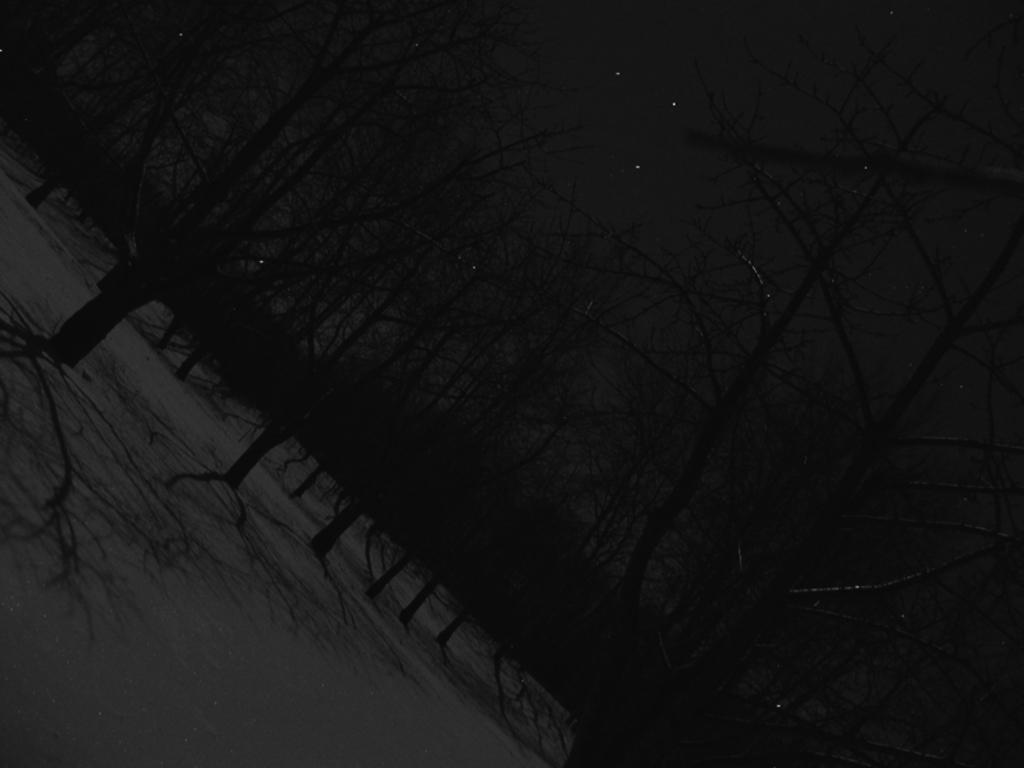What type of vegetation can be seen in the image? There are trees in the image. What celestial objects can be seen in the sky? Stars are visible in the sky. What is the lighting condition in the image? The image was taken in the dark. What is the interest rate on the van in the image? There is no van present in the image, and therefore no interest rate can be determined. 